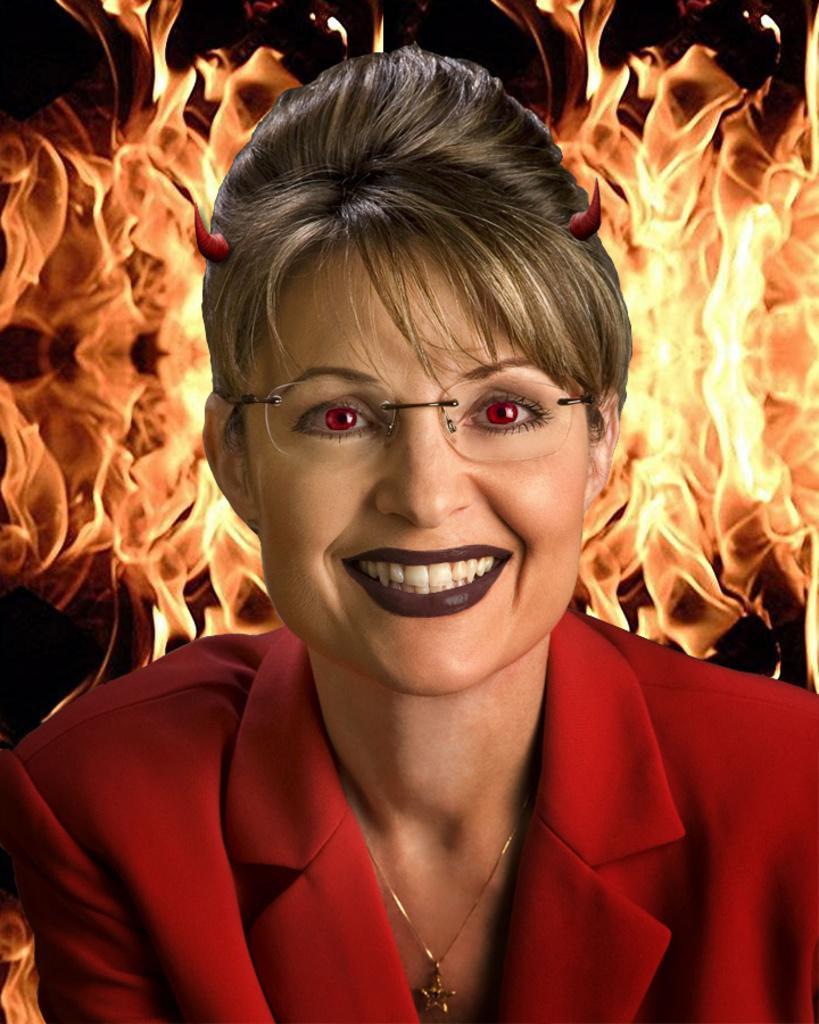Please provide a concise description of this image. This is an edited image. In this image we can see one woman in red dress wearing spectacles and smiling. It looks like animated fire in the background and the background is dark. 